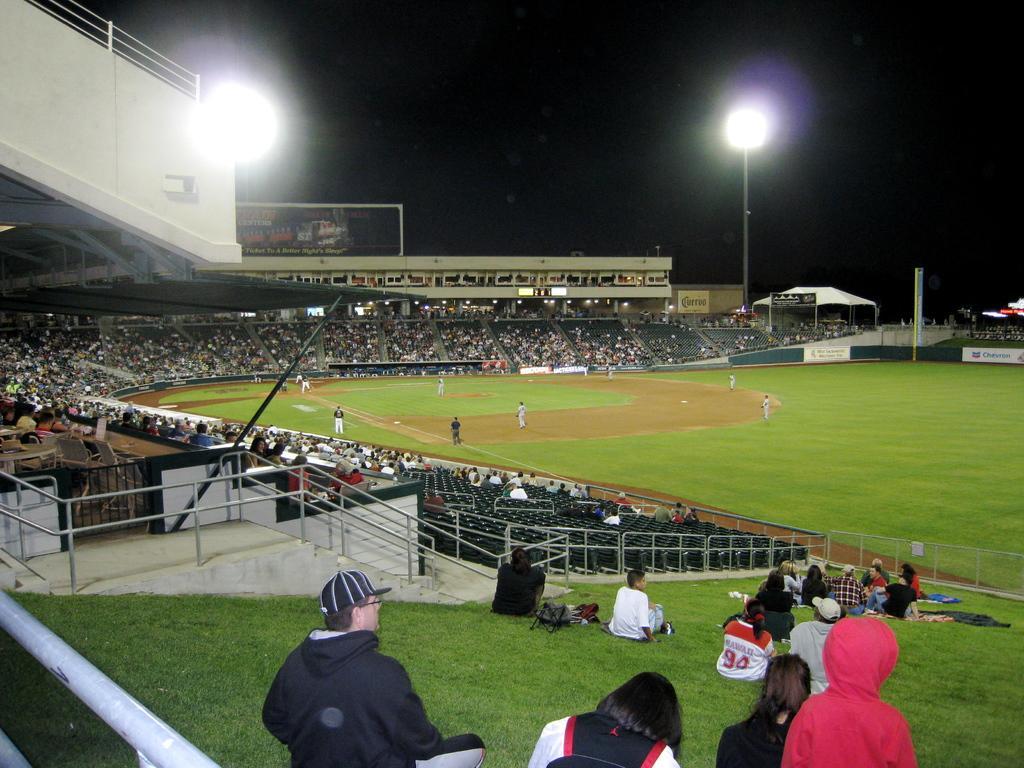Can you describe this image briefly? In the foreground of the image we can see group of persons. One person is wearing spectacles, black dress and a cap. On the right side of the image we can see a group of people sitting on ground, metal barricade, shed. On the left side, we can see group of audience. In the center of the image we can see group of wearing dress are standing on the ground. In the background, we can see a hoarding with text, light poles and the sky. 